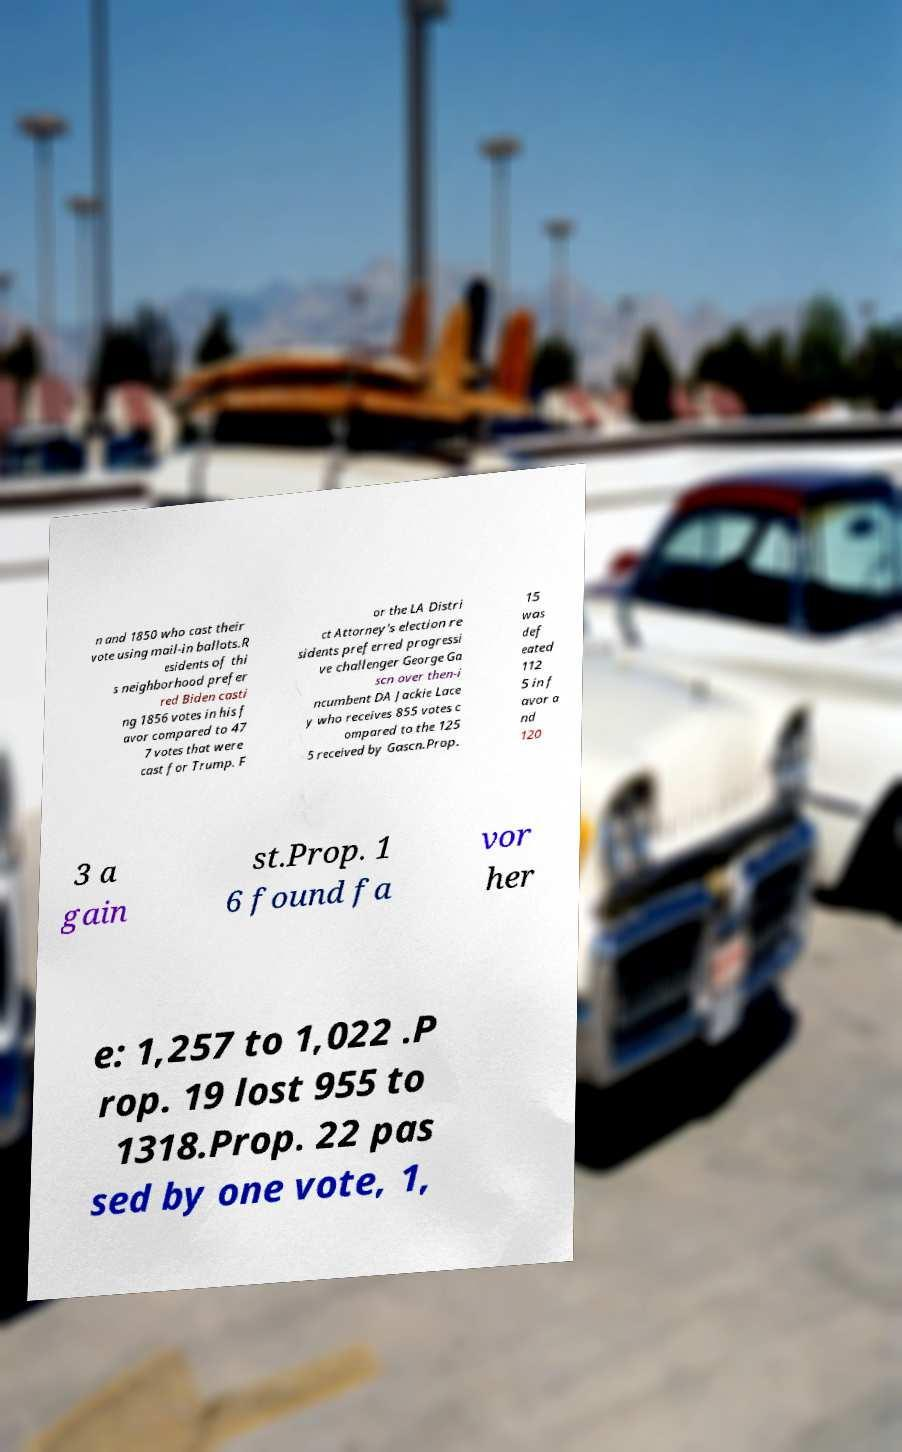I need the written content from this picture converted into text. Can you do that? n and 1850 who cast their vote using mail-in ballots.R esidents of thi s neighborhood prefer red Biden casti ng 1856 votes in his f avor compared to 47 7 votes that were cast for Trump. F or the LA Distri ct Attorney's election re sidents preferred progressi ve challenger George Ga scn over then-i ncumbent DA Jackie Lace y who receives 855 votes c ompared to the 125 5 received by Gascn.Prop. 15 was def eated 112 5 in f avor a nd 120 3 a gain st.Prop. 1 6 found fa vor her e: 1,257 to 1,022 .P rop. 19 lost 955 to 1318.Prop. 22 pas sed by one vote, 1, 